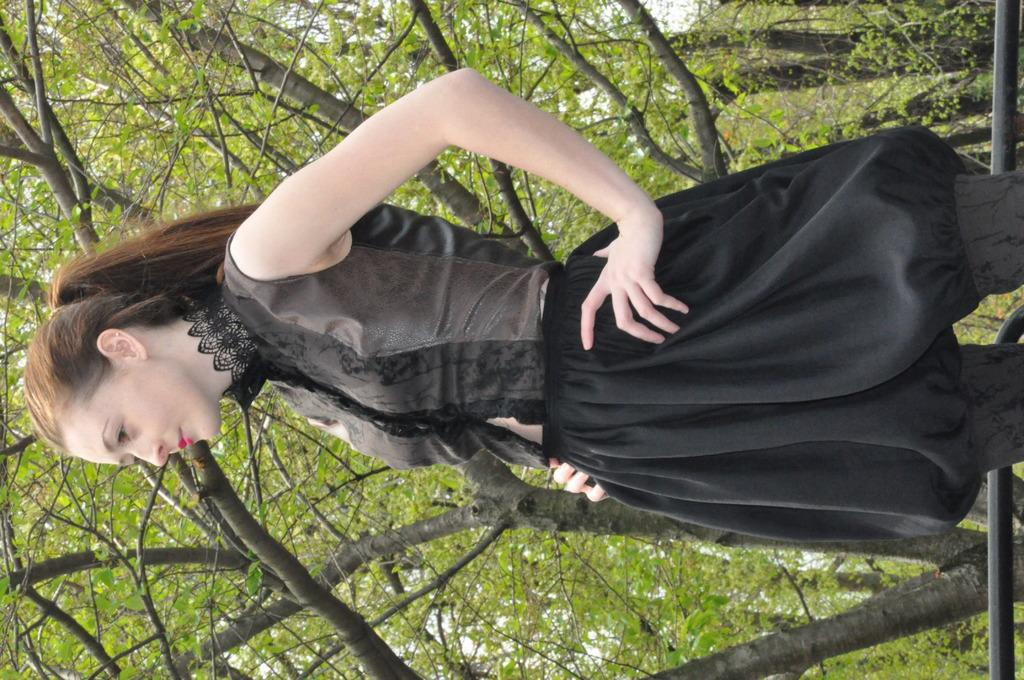What is the main subject in the foreground of the image? There is a person standing in the foreground of the image. What can be seen in the background of the image? There are many trees in the background of the image. Can you see a goat eating celery near the water in the image? There is no goat, celery, or water present in the image. 